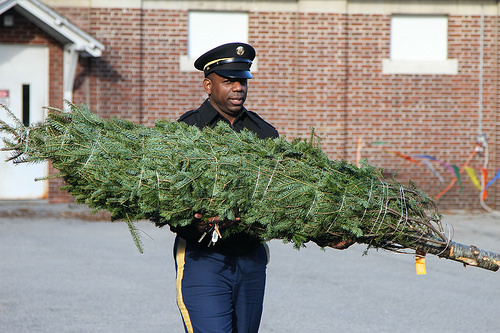<image>
Is the tree behind the man? No. The tree is not behind the man. From this viewpoint, the tree appears to be positioned elsewhere in the scene. Is there a wall in front of the tree? No. The wall is not in front of the tree. The spatial positioning shows a different relationship between these objects. 